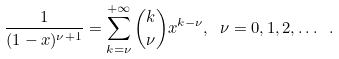Convert formula to latex. <formula><loc_0><loc_0><loc_500><loc_500>\frac { 1 } { ( 1 - x ) ^ { \nu + 1 } } = \sum _ { k = \nu } ^ { + \infty } { k \choose \nu } x ^ { k - \nu } , \ \nu = 0 , 1 , 2 , \dots \ .</formula> 